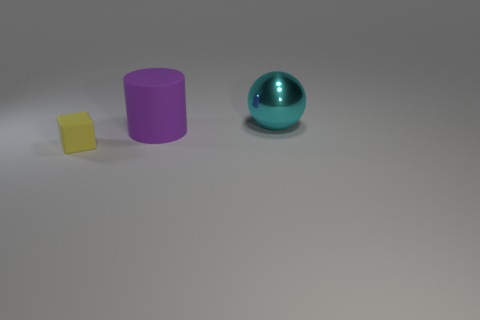Can you describe the colors of the objects in the image? Certainly! There are three objects in the image: a yellow cube, a purple cylinder, and a shiny cyan sphere. The colors are distinct and provide a striking visual contrast against the neutral backdrop. 